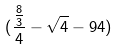Convert formula to latex. <formula><loc_0><loc_0><loc_500><loc_500>( \frac { \frac { 8 } { 3 } } { 4 } - \sqrt { 4 } - 9 4 )</formula> 